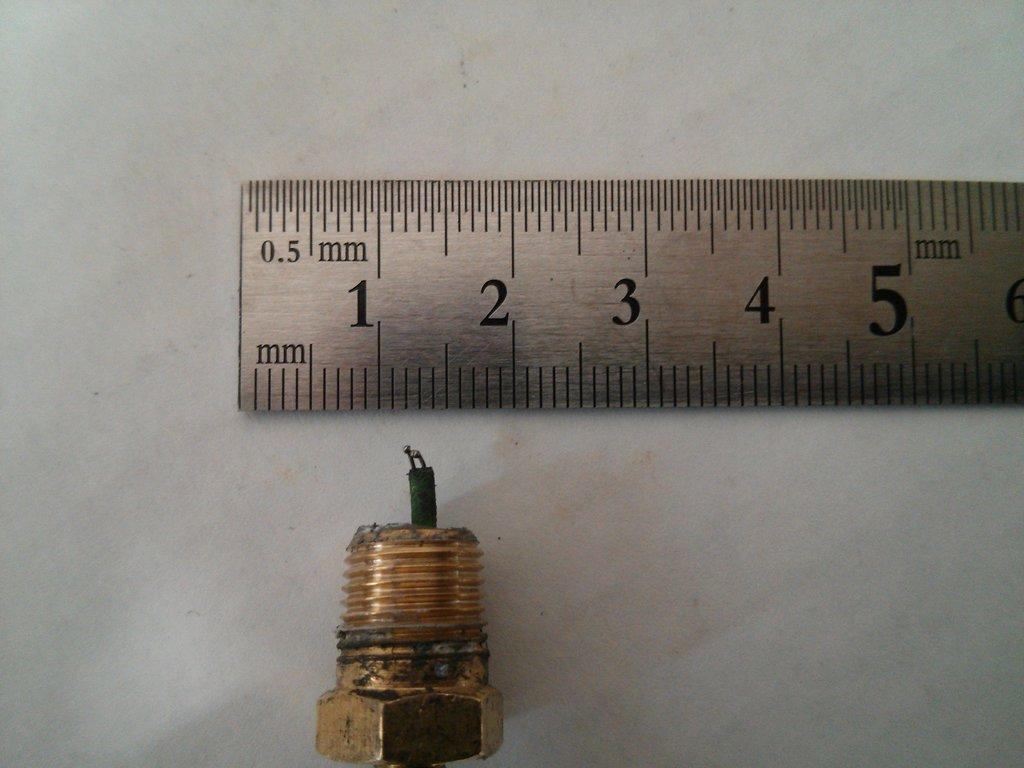<image>
Describe the image concisely. A threaded brass fitting with two wires protruding and a hexagonal top near a ruler depicting millimeters. 